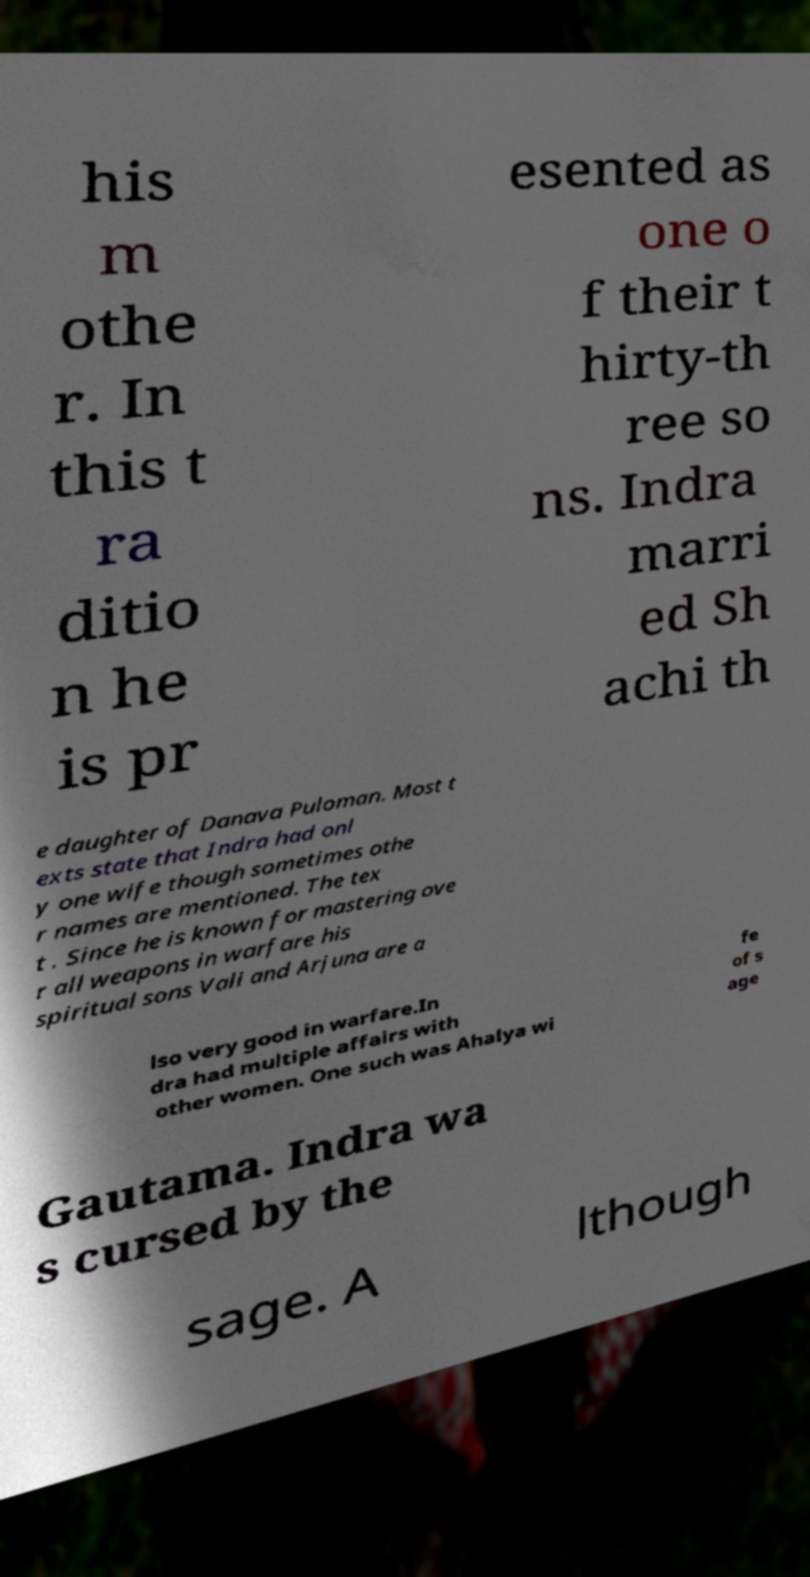I need the written content from this picture converted into text. Can you do that? his m othe r. In this t ra ditio n he is pr esented as one o f their t hirty-th ree so ns. Indra marri ed Sh achi th e daughter of Danava Puloman. Most t exts state that Indra had onl y one wife though sometimes othe r names are mentioned. The tex t . Since he is known for mastering ove r all weapons in warfare his spiritual sons Vali and Arjuna are a lso very good in warfare.In dra had multiple affairs with other women. One such was Ahalya wi fe of s age Gautama. Indra wa s cursed by the sage. A lthough 